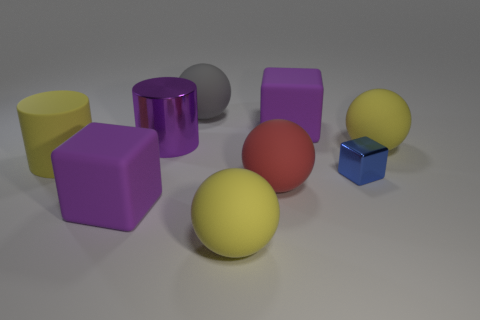What material is the red object that is the same shape as the large gray thing?
Keep it short and to the point. Rubber. There is a big purple matte object right of the big yellow matte sphere that is in front of the yellow rubber cylinder; are there any yellow balls that are on the right side of it?
Provide a succinct answer. Yes. What number of other objects are the same color as the metal block?
Provide a short and direct response. 0. How many big objects are both in front of the big red object and on the right side of the gray ball?
Provide a short and direct response. 1. The large red rubber thing has what shape?
Make the answer very short. Sphere. How many other things are there of the same material as the small cube?
Keep it short and to the point. 1. What is the color of the metallic cylinder that is left of the yellow sphere that is on the left side of the large purple object on the right side of the big metal thing?
Give a very brief answer. Purple. There is a yellow cylinder that is the same size as the gray object; what is its material?
Provide a short and direct response. Rubber. What number of things are purple rubber things that are behind the small blue metal cube or brown balls?
Provide a short and direct response. 1. Is there a large yellow block?
Your response must be concise. No. 